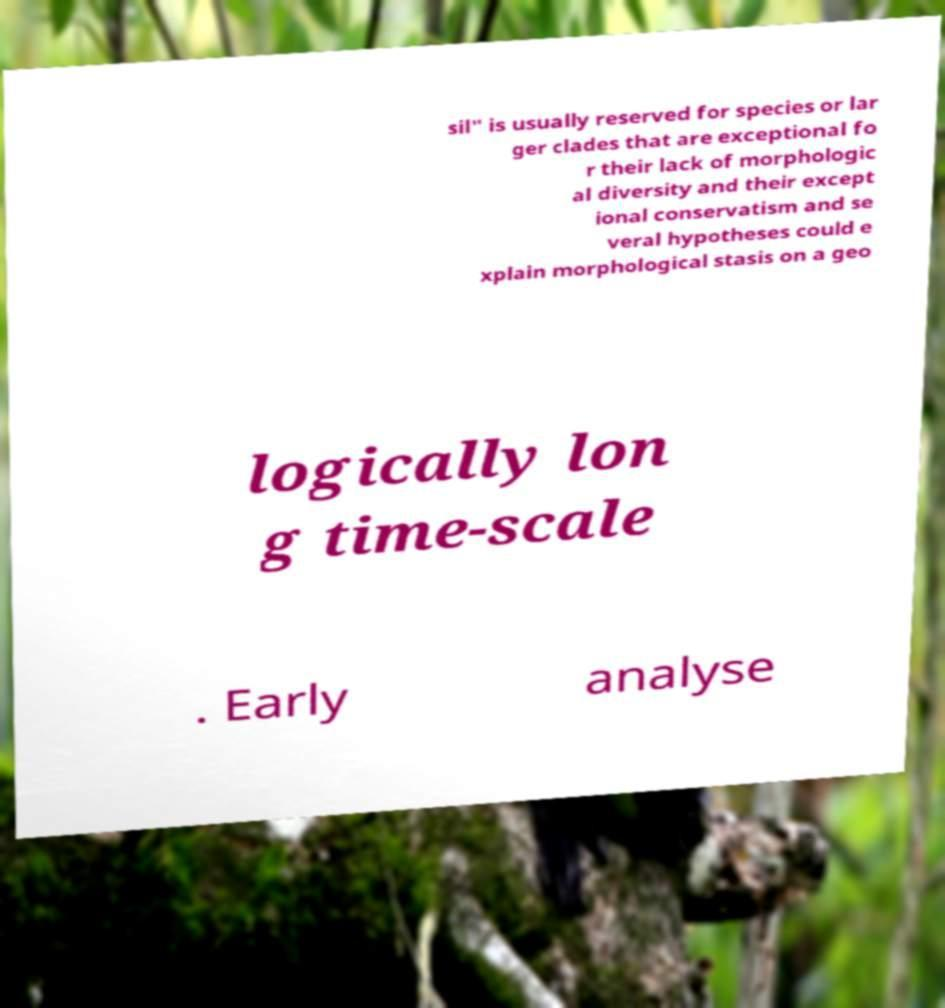Could you extract and type out the text from this image? sil" is usually reserved for species or lar ger clades that are exceptional fo r their lack of morphologic al diversity and their except ional conservatism and se veral hypotheses could e xplain morphological stasis on a geo logically lon g time-scale . Early analyse 